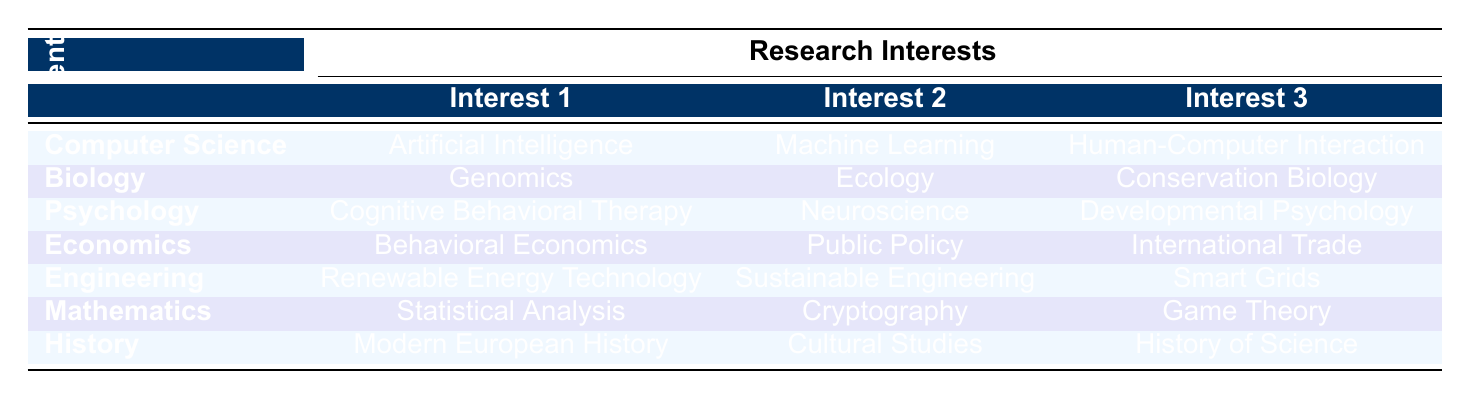What are the research interests of Dr. Emily Chen? From the table, Dr. Emily Chen is in the Computer Science department, and her research interests listed are Artificial Intelligence, Machine Learning, and Human-Computer Interaction.
Answer: Artificial Intelligence, Machine Learning, Human-Computer Interaction Which department does Dr. Sarah Patel belong to? By looking at the table, I can see that Dr. Sarah Patel is listed under the Engineering department.
Answer: Engineering Is "Ecology" a research interest for any faculty member? Checking the table, I see that "Ecology" is indeed listed as one of the research interests for Dr. John Smith in the Biology department.
Answer: Yes How many research interests does Dr. Robert Lee have? The table shows that Dr. Robert Lee, who belongs to the Economics department, has three listed research interests: Behavioral Economics, Public Policy, and International Trade. So he has three research interests.
Answer: Three Which faculty member is working on "Sustainable Engineering"? According to the table, Dr. Sarah Patel from the Engineering department is focused on Sustainable Engineering.
Answer: Dr. Sarah Patel What is the total number of unique research interests across all faculty? By inspecting the table, we can count the research interests per faculty member and note that there are 18 unique research interests across the 7 faculty members: 3 for each of the 6 faculty members minus any duplicates. Listing them individually shows that no two faculty members share the exact same set of interests. Therefore, the total is 18.
Answer: 18 Does any faculty member have interests in both "Neuroscience" and "Public Policy"? Looking at the table, Dr. Maria Gonzalez has "Neuroscience" as a research interest, and Dr. Robert Lee has "Public Policy." However, these two faculty members do not share any research interests, so the answer to the question is no.
Answer: No Identify the faculty member with research interests in "Cultural Studies." Referring to the table, Dr. Lisa Wong from the History department has "Cultural Studies" listed as one of her research interests.
Answer: Dr. Lisa Wong What are the three primary research interests listed for the Psychology department? The table indicates that for the Psychology department (home to Dr. Maria Gonzalez), the three primary research interests are Cognitive Behavioral Therapy, Neuroscience, and Developmental Psychology.
Answer: Cognitive Behavioral Therapy, Neuroscience, Developmental Psychology 